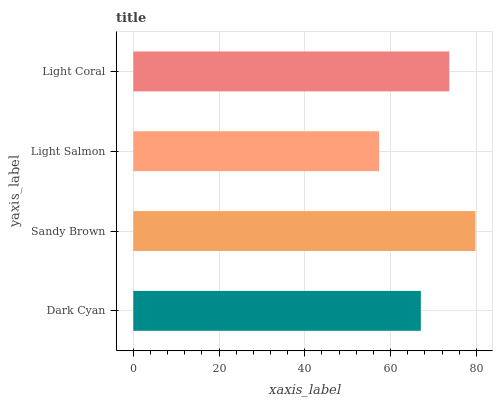Is Light Salmon the minimum?
Answer yes or no. Yes. Is Sandy Brown the maximum?
Answer yes or no. Yes. Is Sandy Brown the minimum?
Answer yes or no. No. Is Light Salmon the maximum?
Answer yes or no. No. Is Sandy Brown greater than Light Salmon?
Answer yes or no. Yes. Is Light Salmon less than Sandy Brown?
Answer yes or no. Yes. Is Light Salmon greater than Sandy Brown?
Answer yes or no. No. Is Sandy Brown less than Light Salmon?
Answer yes or no. No. Is Light Coral the high median?
Answer yes or no. Yes. Is Dark Cyan the low median?
Answer yes or no. Yes. Is Dark Cyan the high median?
Answer yes or no. No. Is Light Salmon the low median?
Answer yes or no. No. 